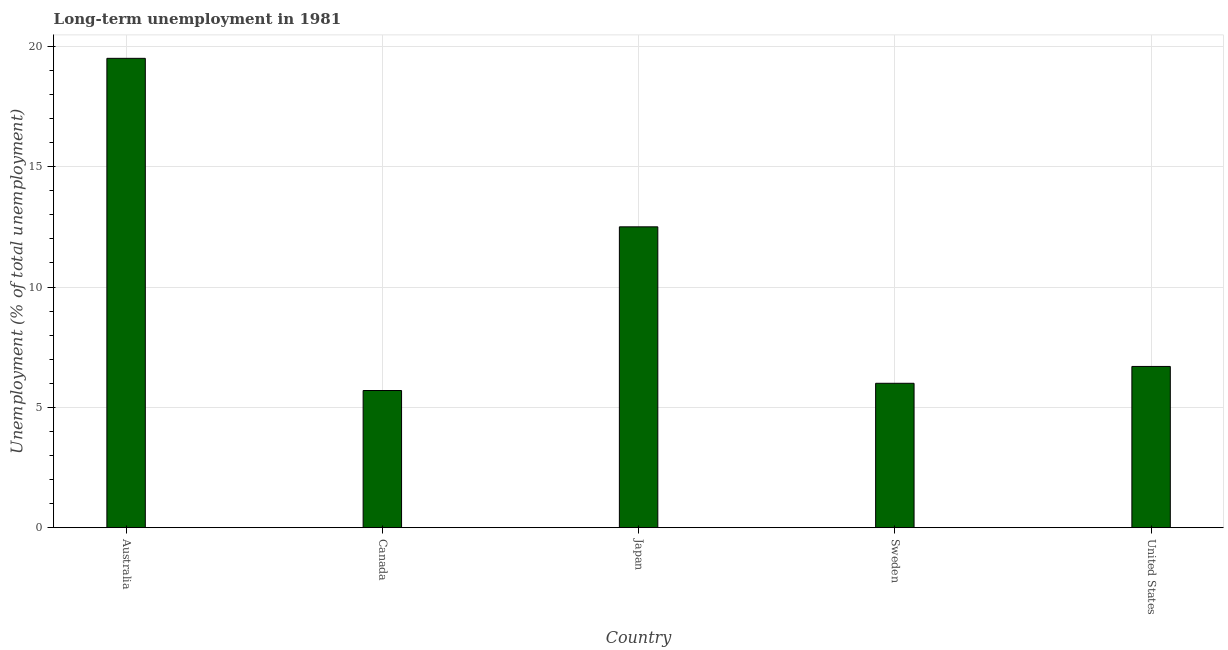What is the title of the graph?
Offer a terse response. Long-term unemployment in 1981. What is the label or title of the Y-axis?
Make the answer very short. Unemployment (% of total unemployment). What is the long-term unemployment in Japan?
Offer a terse response. 12.5. Across all countries, what is the minimum long-term unemployment?
Provide a short and direct response. 5.7. In which country was the long-term unemployment maximum?
Your response must be concise. Australia. What is the sum of the long-term unemployment?
Your response must be concise. 50.4. What is the average long-term unemployment per country?
Offer a very short reply. 10.08. What is the median long-term unemployment?
Offer a terse response. 6.7. What is the ratio of the long-term unemployment in Japan to that in United States?
Make the answer very short. 1.87. Is the long-term unemployment in Japan less than that in United States?
Provide a short and direct response. No. Is the difference between the long-term unemployment in Canada and United States greater than the difference between any two countries?
Make the answer very short. No. Is the sum of the long-term unemployment in Australia and United States greater than the maximum long-term unemployment across all countries?
Keep it short and to the point. Yes. What is the difference between the highest and the lowest long-term unemployment?
Provide a succinct answer. 13.8. In how many countries, is the long-term unemployment greater than the average long-term unemployment taken over all countries?
Ensure brevity in your answer.  2. How many bars are there?
Offer a terse response. 5. How many countries are there in the graph?
Keep it short and to the point. 5. Are the values on the major ticks of Y-axis written in scientific E-notation?
Provide a succinct answer. No. What is the Unemployment (% of total unemployment) in Canada?
Give a very brief answer. 5.7. What is the Unemployment (% of total unemployment) of Japan?
Provide a succinct answer. 12.5. What is the Unemployment (% of total unemployment) in Sweden?
Offer a terse response. 6. What is the Unemployment (% of total unemployment) in United States?
Provide a short and direct response. 6.7. What is the difference between the Unemployment (% of total unemployment) in Canada and Japan?
Your response must be concise. -6.8. What is the difference between the Unemployment (% of total unemployment) in Canada and Sweden?
Ensure brevity in your answer.  -0.3. What is the difference between the Unemployment (% of total unemployment) in Japan and United States?
Provide a succinct answer. 5.8. What is the difference between the Unemployment (% of total unemployment) in Sweden and United States?
Make the answer very short. -0.7. What is the ratio of the Unemployment (% of total unemployment) in Australia to that in Canada?
Offer a terse response. 3.42. What is the ratio of the Unemployment (% of total unemployment) in Australia to that in Japan?
Ensure brevity in your answer.  1.56. What is the ratio of the Unemployment (% of total unemployment) in Australia to that in Sweden?
Ensure brevity in your answer.  3.25. What is the ratio of the Unemployment (% of total unemployment) in Australia to that in United States?
Keep it short and to the point. 2.91. What is the ratio of the Unemployment (% of total unemployment) in Canada to that in Japan?
Provide a succinct answer. 0.46. What is the ratio of the Unemployment (% of total unemployment) in Canada to that in Sweden?
Your response must be concise. 0.95. What is the ratio of the Unemployment (% of total unemployment) in Canada to that in United States?
Your answer should be compact. 0.85. What is the ratio of the Unemployment (% of total unemployment) in Japan to that in Sweden?
Make the answer very short. 2.08. What is the ratio of the Unemployment (% of total unemployment) in Japan to that in United States?
Your answer should be very brief. 1.87. What is the ratio of the Unemployment (% of total unemployment) in Sweden to that in United States?
Keep it short and to the point. 0.9. 